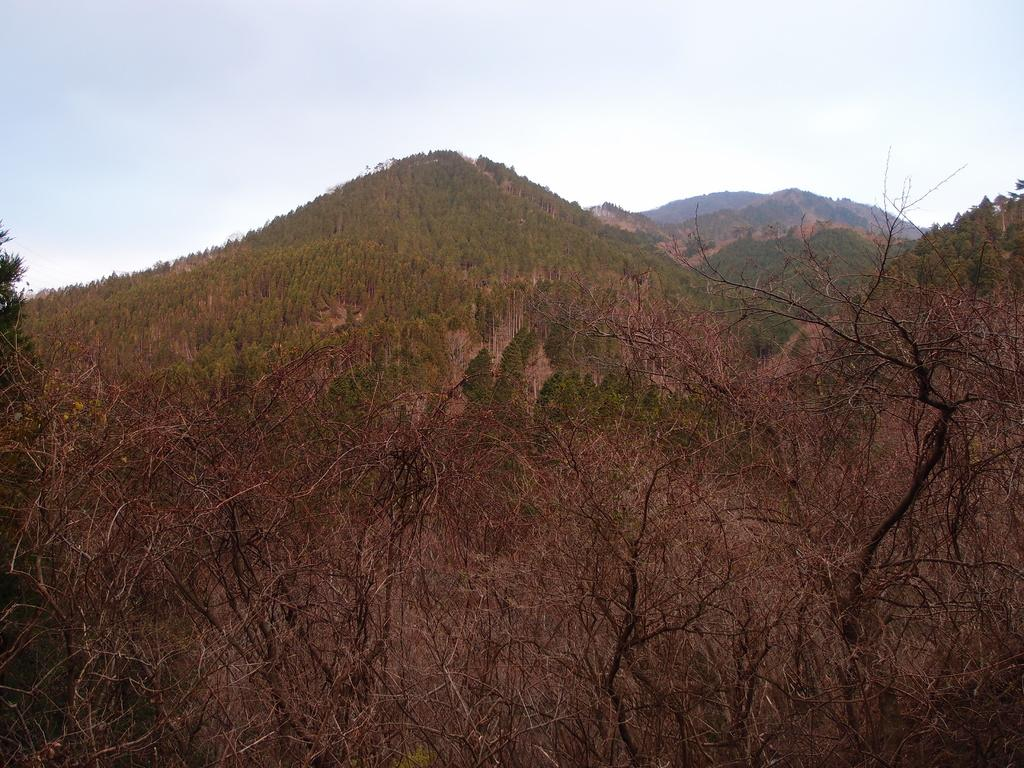What type of vegetation is present in the image? There are dried plants in the image. What natural landforms can be seen in the image? Mountains are visible in the image. How are the mountains covered? The mountains are covered with trees. Is there a woman standing on top of the mountain in the image? There is no woman present in the image; it only features dried plants and mountains covered with trees. 